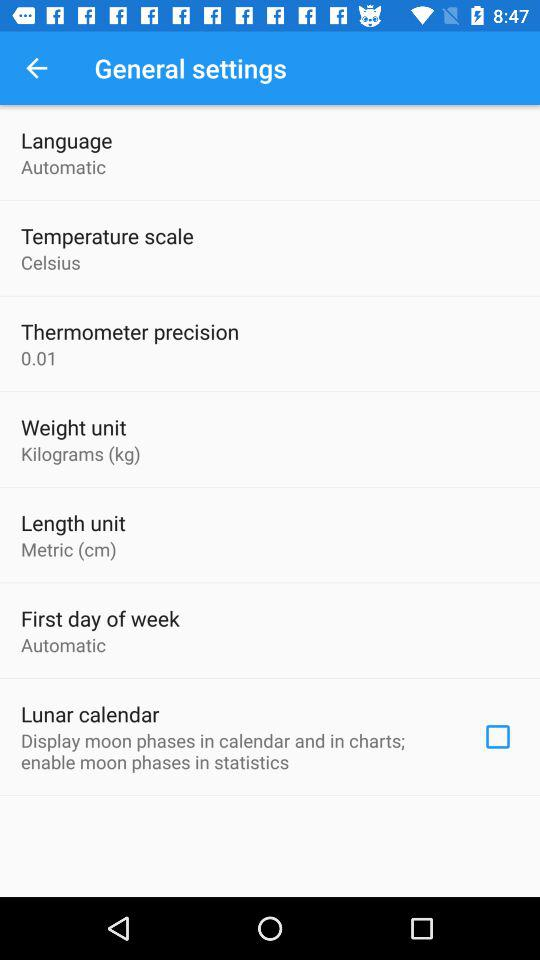What is the unit of weight? The unit of weight is kilograms. 